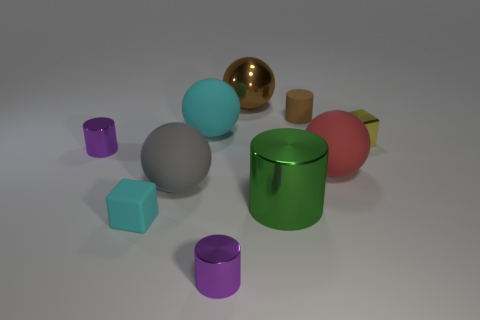There is a small thing that is made of the same material as the small cyan cube; what is its color?
Your answer should be very brief. Brown. How many large red spheres have the same material as the big cylinder?
Provide a short and direct response. 0. What color is the sphere that is on the right side of the large brown sphere that is to the left of the matte sphere that is on the right side of the brown matte cylinder?
Offer a very short reply. Red. Does the red matte thing have the same size as the cyan block?
Offer a terse response. No. What number of objects are either purple metallic objects in front of the matte block or big gray rubber things?
Your response must be concise. 2. Is the big green shiny object the same shape as the brown rubber object?
Give a very brief answer. Yes. What number of other things are the same size as the green cylinder?
Make the answer very short. 4. What color is the rubber cylinder?
Your answer should be very brief. Brown. How many large objects are brown shiny balls or gray blocks?
Offer a very short reply. 1. Do the sphere behind the big cyan thing and the cyan thing that is behind the large green metallic cylinder have the same size?
Your answer should be very brief. Yes. 